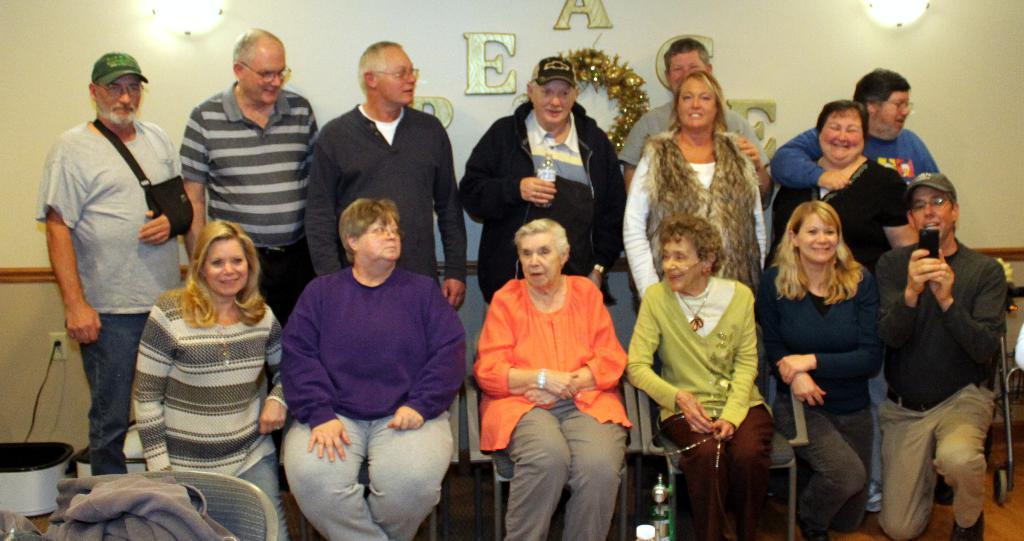Can you describe this image briefly? In the foreground of the picture there are people. On the right there is a wheelchair. On the left there is a chair and a cloth. In the background there are lights, wreath and text on the wall. 